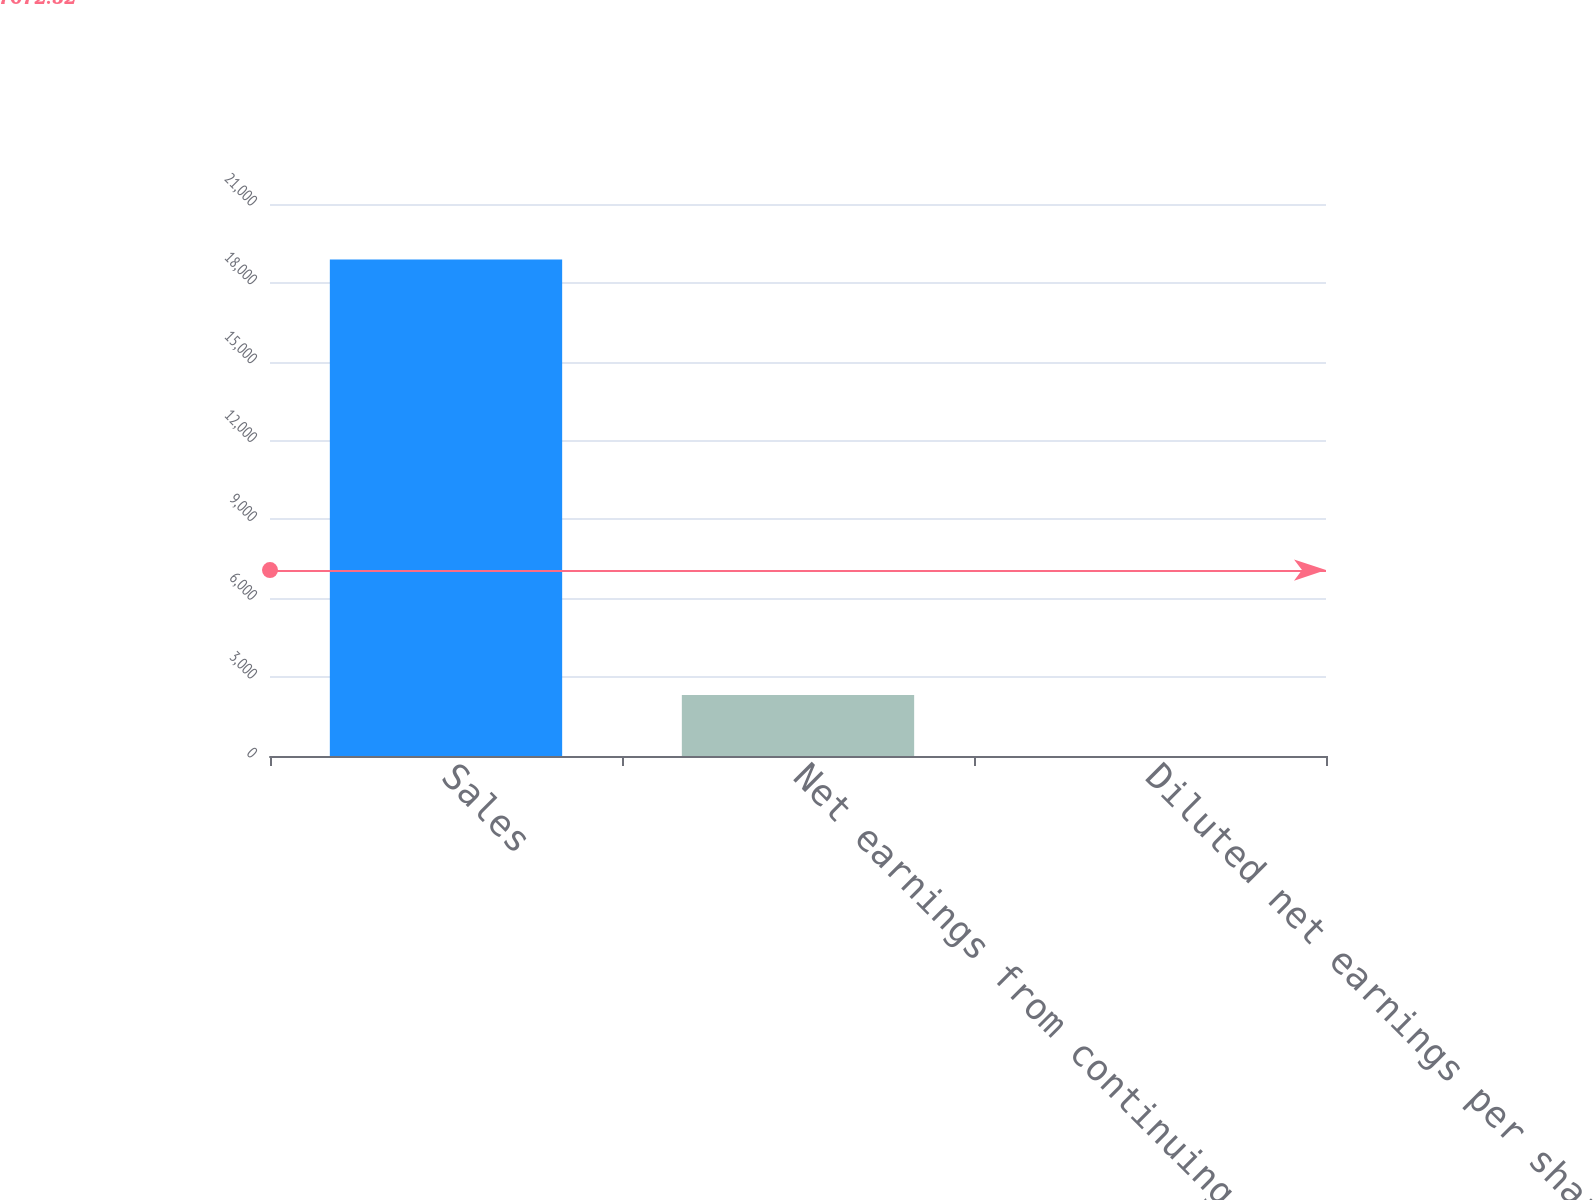Convert chart. <chart><loc_0><loc_0><loc_500><loc_500><bar_chart><fcel>Sales<fcel>Net earnings from continuing<fcel>Diluted net earnings per share<nl><fcel>18891.7<fcel>2322.6<fcel>3.27<nl></chart> 